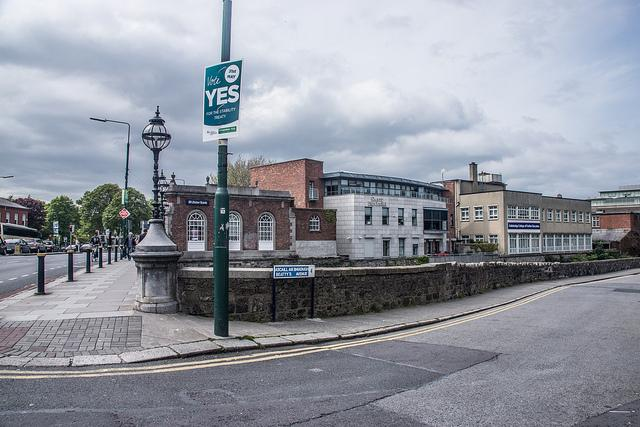What weather might be imminent here?

Choices:
A) tornado
B) sun
C) rain
D) earthquake rain 